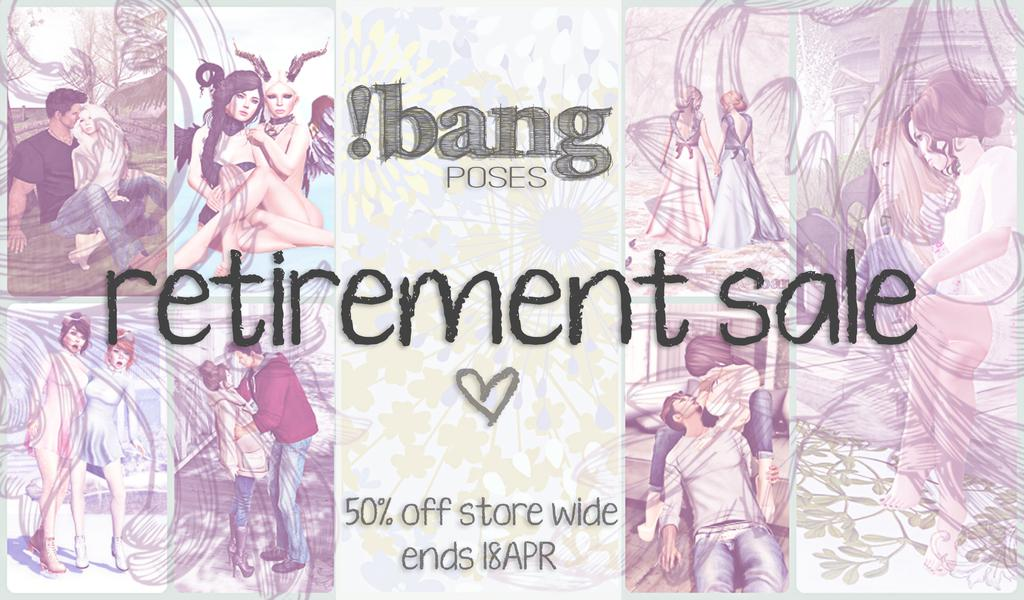What is present in the image that features a visual representation? There is a poster in the image. What can be seen on the poster? There are people depicted on the poster. What else is present on the poster besides the images of people? There is text written on the poster. How many bags can be seen on the poster in the image? There are no bags present on the poster in the image. What type of men are depicted on the poster in the image? There are no men depicted on the poster in the image. 